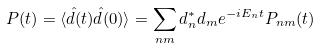Convert formula to latex. <formula><loc_0><loc_0><loc_500><loc_500>P ( t ) = \langle \hat { d } ( t ) \hat { d } ( 0 ) \rangle = \sum _ { n m } d ^ { \ast } _ { n } d _ { m } e ^ { - i E _ { n } t } P _ { n m } ( t )</formula> 